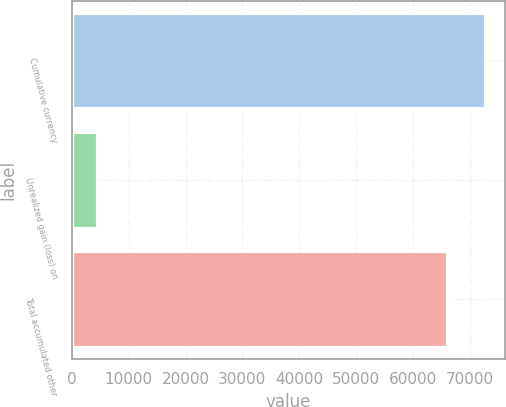Convert chart. <chart><loc_0><loc_0><loc_500><loc_500><bar_chart><fcel>Cumulative currency<fcel>Unrealized gain (loss) on<fcel>Total accumulated other<nl><fcel>72576.9<fcel>4428<fcel>65979<nl></chart> 